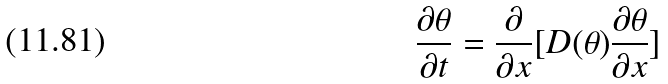Convert formula to latex. <formula><loc_0><loc_0><loc_500><loc_500>\frac { \partial \theta } { \partial t } = \frac { \partial } { \partial x } [ D ( \theta ) \frac { \partial \theta } { \partial x } ]</formula> 